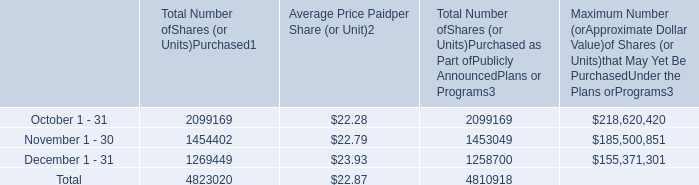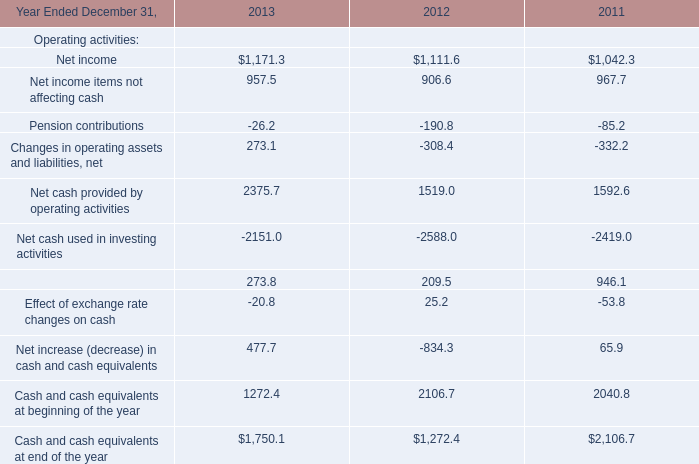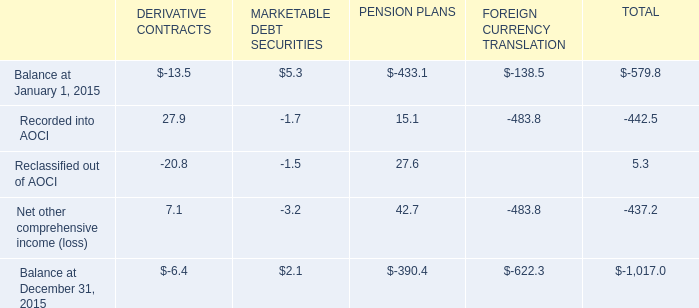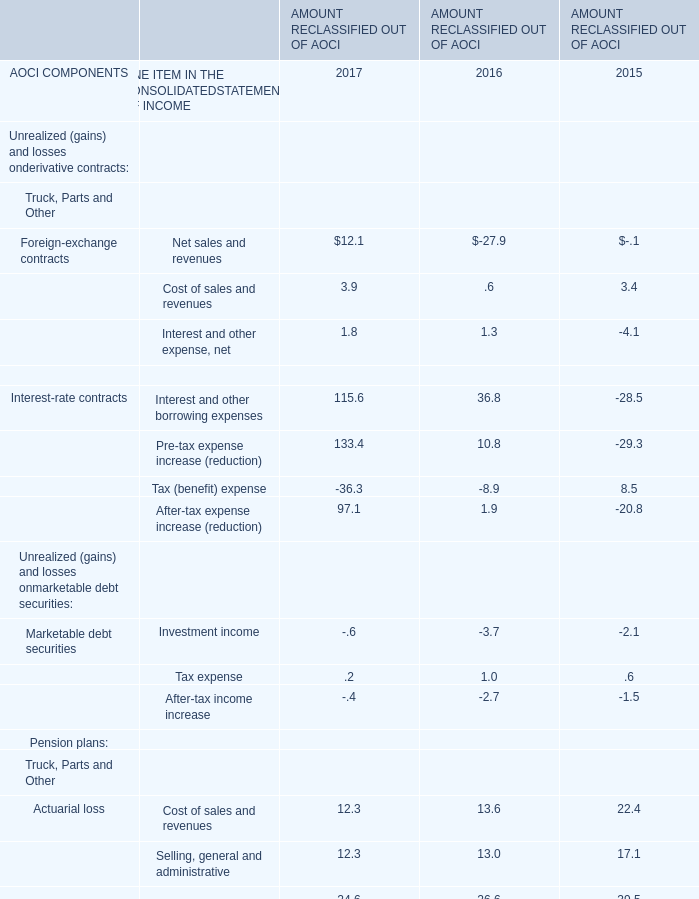What is the percentage of Recorded into AOCI in relation to the total in 2015? 
Computations: (-442.5 / -1017.0)
Answer: 0.4351. 